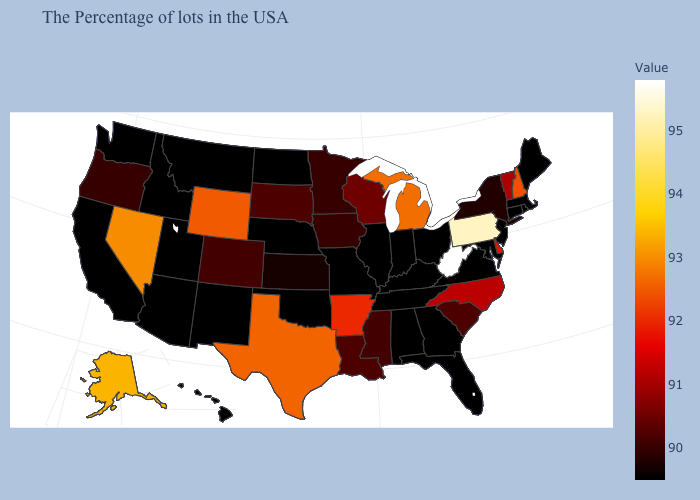Among the states that border Washington , which have the lowest value?
Keep it brief. Idaho. 